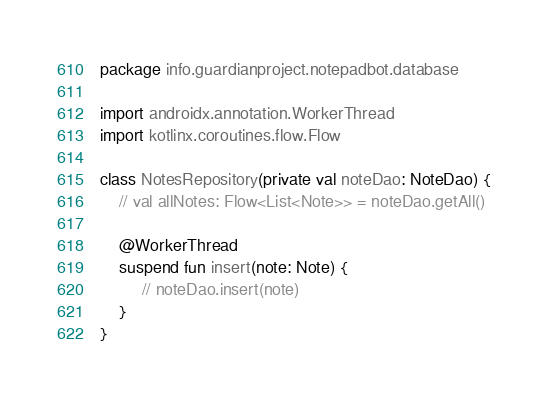<code> <loc_0><loc_0><loc_500><loc_500><_Kotlin_>package info.guardianproject.notepadbot.database

import androidx.annotation.WorkerThread
import kotlinx.coroutines.flow.Flow

class NotesRepository(private val noteDao: NoteDao) {
    // val allNotes: Flow<List<Note>> = noteDao.getAll()

    @WorkerThread
    suspend fun insert(note: Note) {
         // noteDao.insert(note)
    }
}</code> 